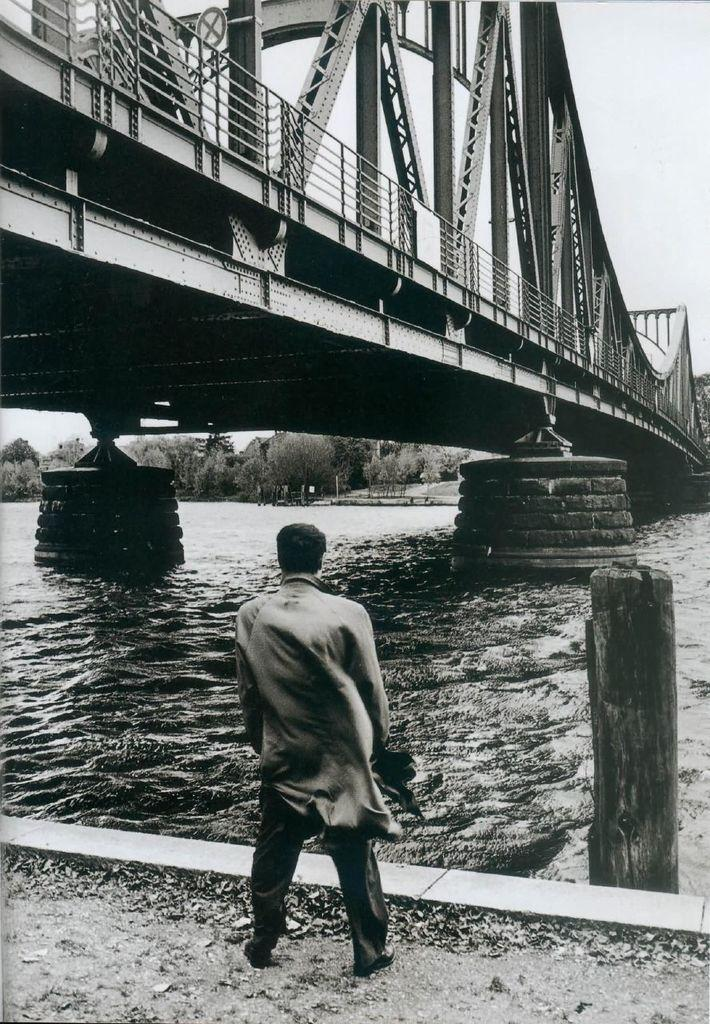What is the main subject of the image? There is a person standing in the image. What can be seen in the background of the image? There is water, trees, and the sky visible in the background of the image. What is the color scheme of the image? The image is black and white in color. What type of jewel is the person wearing in the image? There is no mention of any jewelry in the image, so it cannot be determined if the person is wearing a jewel. 